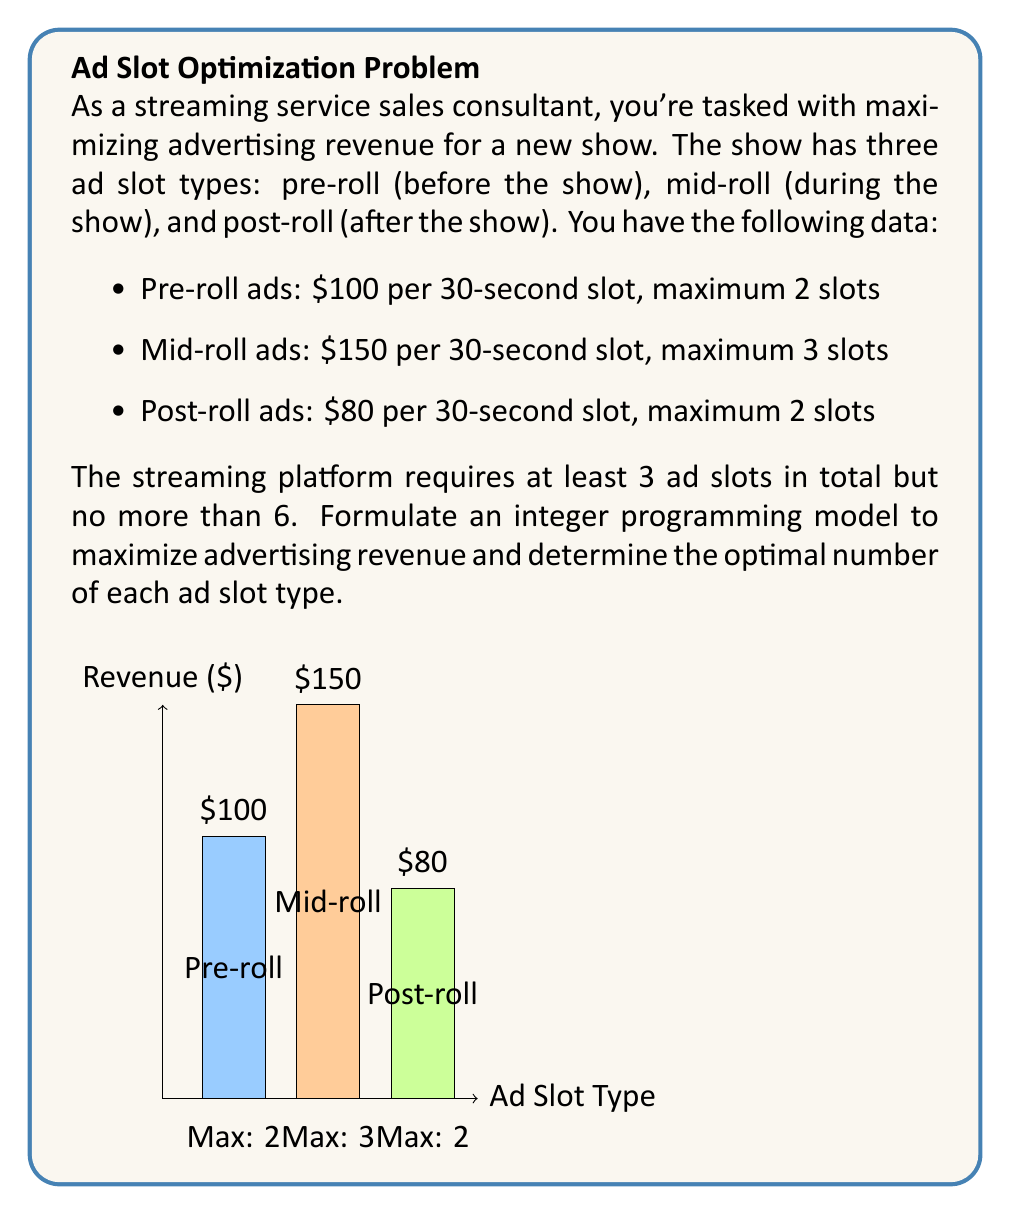Teach me how to tackle this problem. Let's approach this step-by-step:

1) Define variables:
   Let $x_1$, $x_2$, and $x_3$ be the number of pre-roll, mid-roll, and post-roll ad slots, respectively.

2) Objective function:
   Maximize revenue: $Z = 100x_1 + 150x_2 + 80x_3$

3) Constraints:
   a) Maximum slots for each type:
      $x_1 \leq 2$
      $x_2 \leq 3$
      $x_3 \leq 2$

   b) Total slots requirement:
      $3 \leq x_1 + x_2 + x_3 \leq 6$

   c) Integer constraints:
      $x_1, x_2, x_3 \in \mathbb{Z}^+$ (non-negative integers)

4) Solve the integer programming problem:
   We can solve this using branch and bound or other integer programming methods. However, given the small scale of the problem, we can also enumerate all feasible solutions:

   Feasible solutions (x1, x2, x3):
   (1,1,1), (1,1,2), (1,2,1), (1,2,2), (1,3,1), (1,3,2),
   (2,1,1), (2,1,2), (2,2,1), (2,2,2), (2,3,1)

5) Calculate revenue for each solution and find the maximum:
   The highest revenue is achieved with (2,3,1):
   $Z = 100(2) + 150(3) + 80(1) = 200 + 450 + 80 = 730$

Therefore, the optimal solution is to use 2 pre-roll ads, 3 mid-roll ads, and 1 post-roll ad, generating a maximum revenue of $730.
Answer: 2 pre-roll, 3 mid-roll, 1 post-roll; $730 revenue 